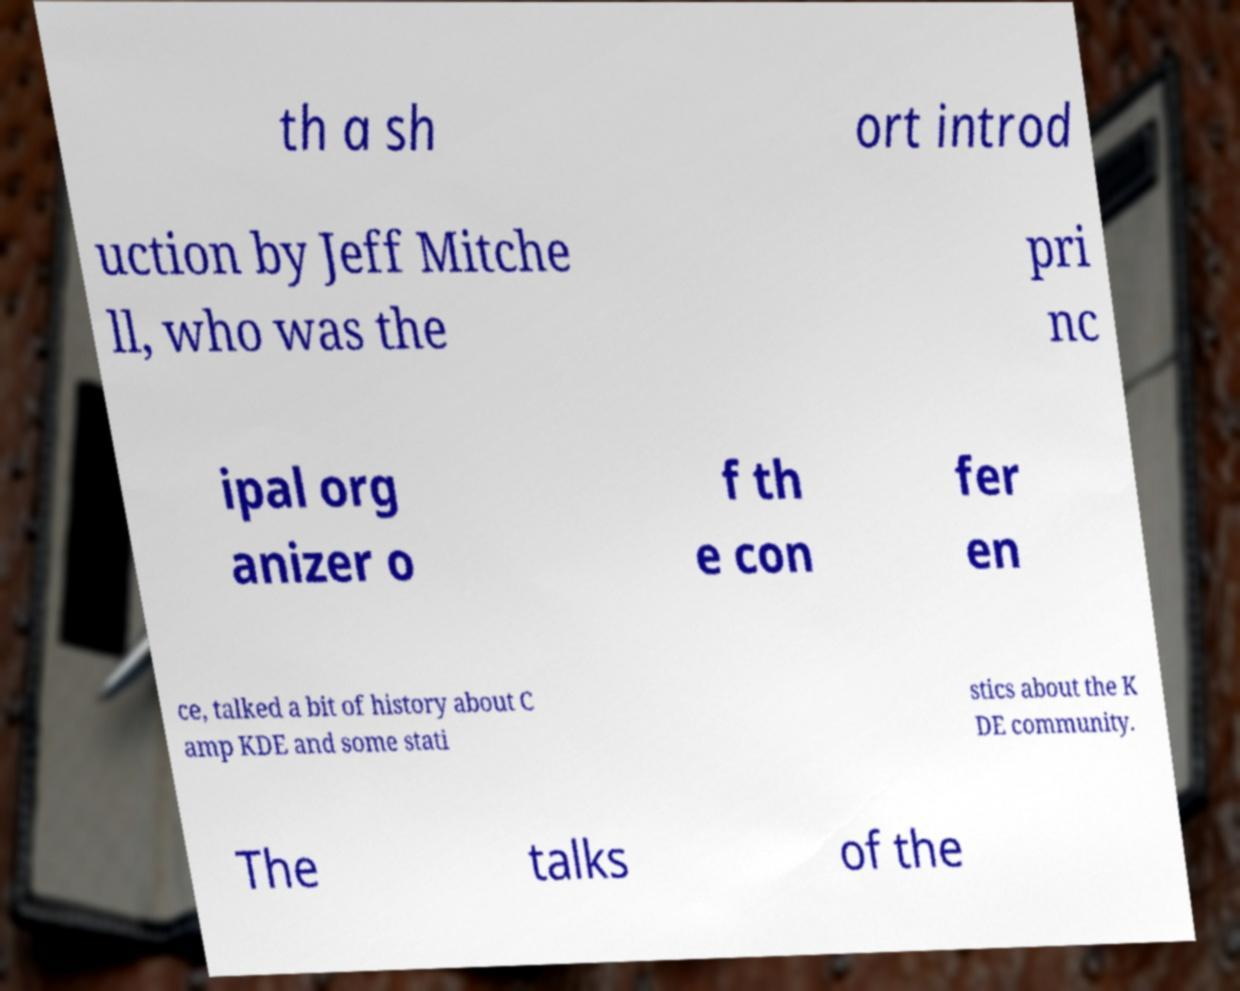What messages or text are displayed in this image? I need them in a readable, typed format. th a sh ort introd uction by Jeff Mitche ll, who was the pri nc ipal org anizer o f th e con fer en ce, talked a bit of history about C amp KDE and some stati stics about the K DE community. The talks of the 